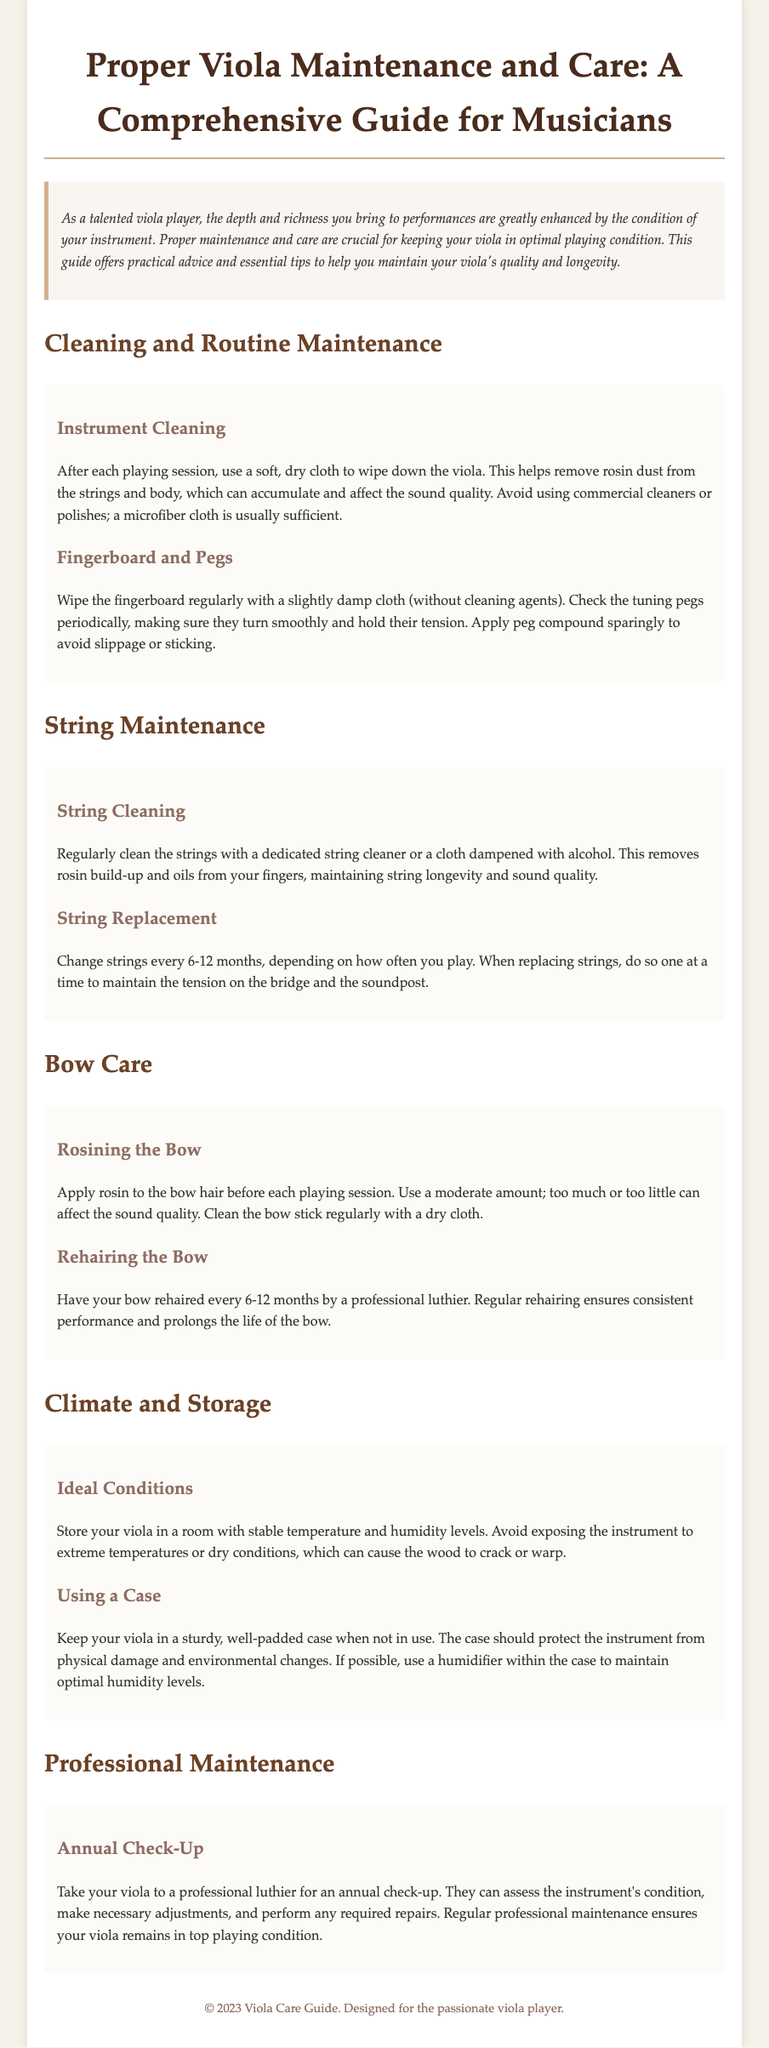What should be used to clean the viola? The document suggests using a soft, dry cloth to wipe down the viola after each playing session.
Answer: Soft, dry cloth How often should the strings be replaced? According to the document, strings should be changed every 6-12 months, depending on playing frequency.
Answer: 6-12 months What should you do with bow hair before playing? The document advises applying rosin to the bow hair before each playing session.
Answer: Rosin What is the purpose of a case for the viola? The document states that a case protects the instrument from physical damage and environmental changes.
Answer: Protect instrument When should you take the viola to a professional luthier? An annual check-up is recommended for the viola, as per the document.
Answer: Annual check-up What material is recommended for cleaning the fingerboard? A slightly damp cloth without cleaning agents is advised for cleaning the fingerboard.
Answer: Slightly damp cloth What does the document suggest using in a case to maintain humidity? It suggests using a humidifier within the case to maintain optimal humidity levels.
Answer: Humidifier What is the preferred condition for storing the viola? The document mentions that it should be stored in stable temperature and humidity levels.
Answer: Stable conditions 